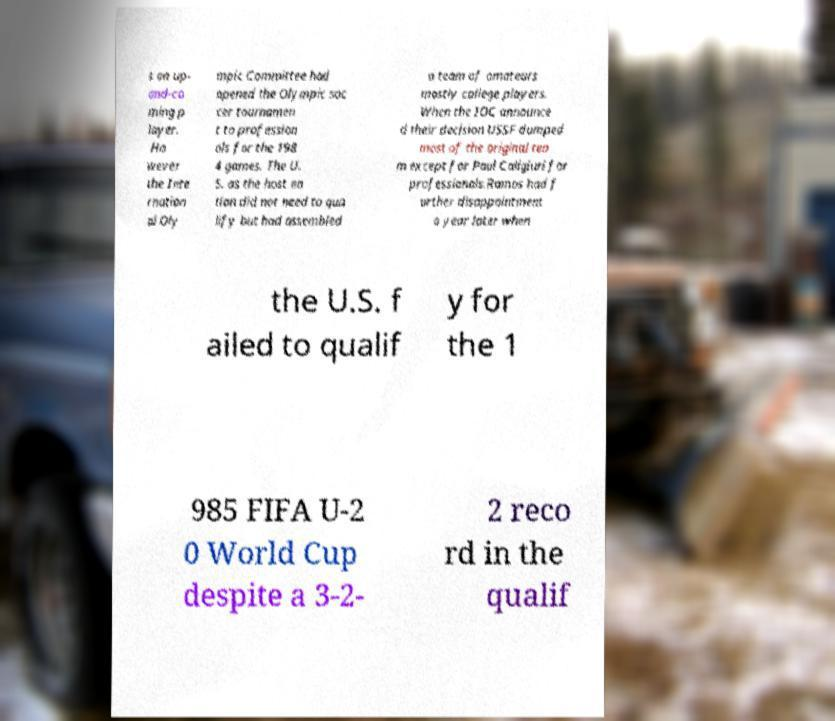Could you assist in decoding the text presented in this image and type it out clearly? s an up- and-co ming p layer. Ho wever the Inte rnation al Oly mpic Committee had opened the Olympic soc cer tournamen t to profession als for the 198 4 games. The U. S. as the host na tion did not need to qua lify but had assembled a team of amateurs mostly college players. When the IOC announce d their decision USSF dumped most of the original tea m except for Paul Caligiuri for professionals.Ramos had f urther disappointment a year later when the U.S. f ailed to qualif y for the 1 985 FIFA U-2 0 World Cup despite a 3-2- 2 reco rd in the qualif 